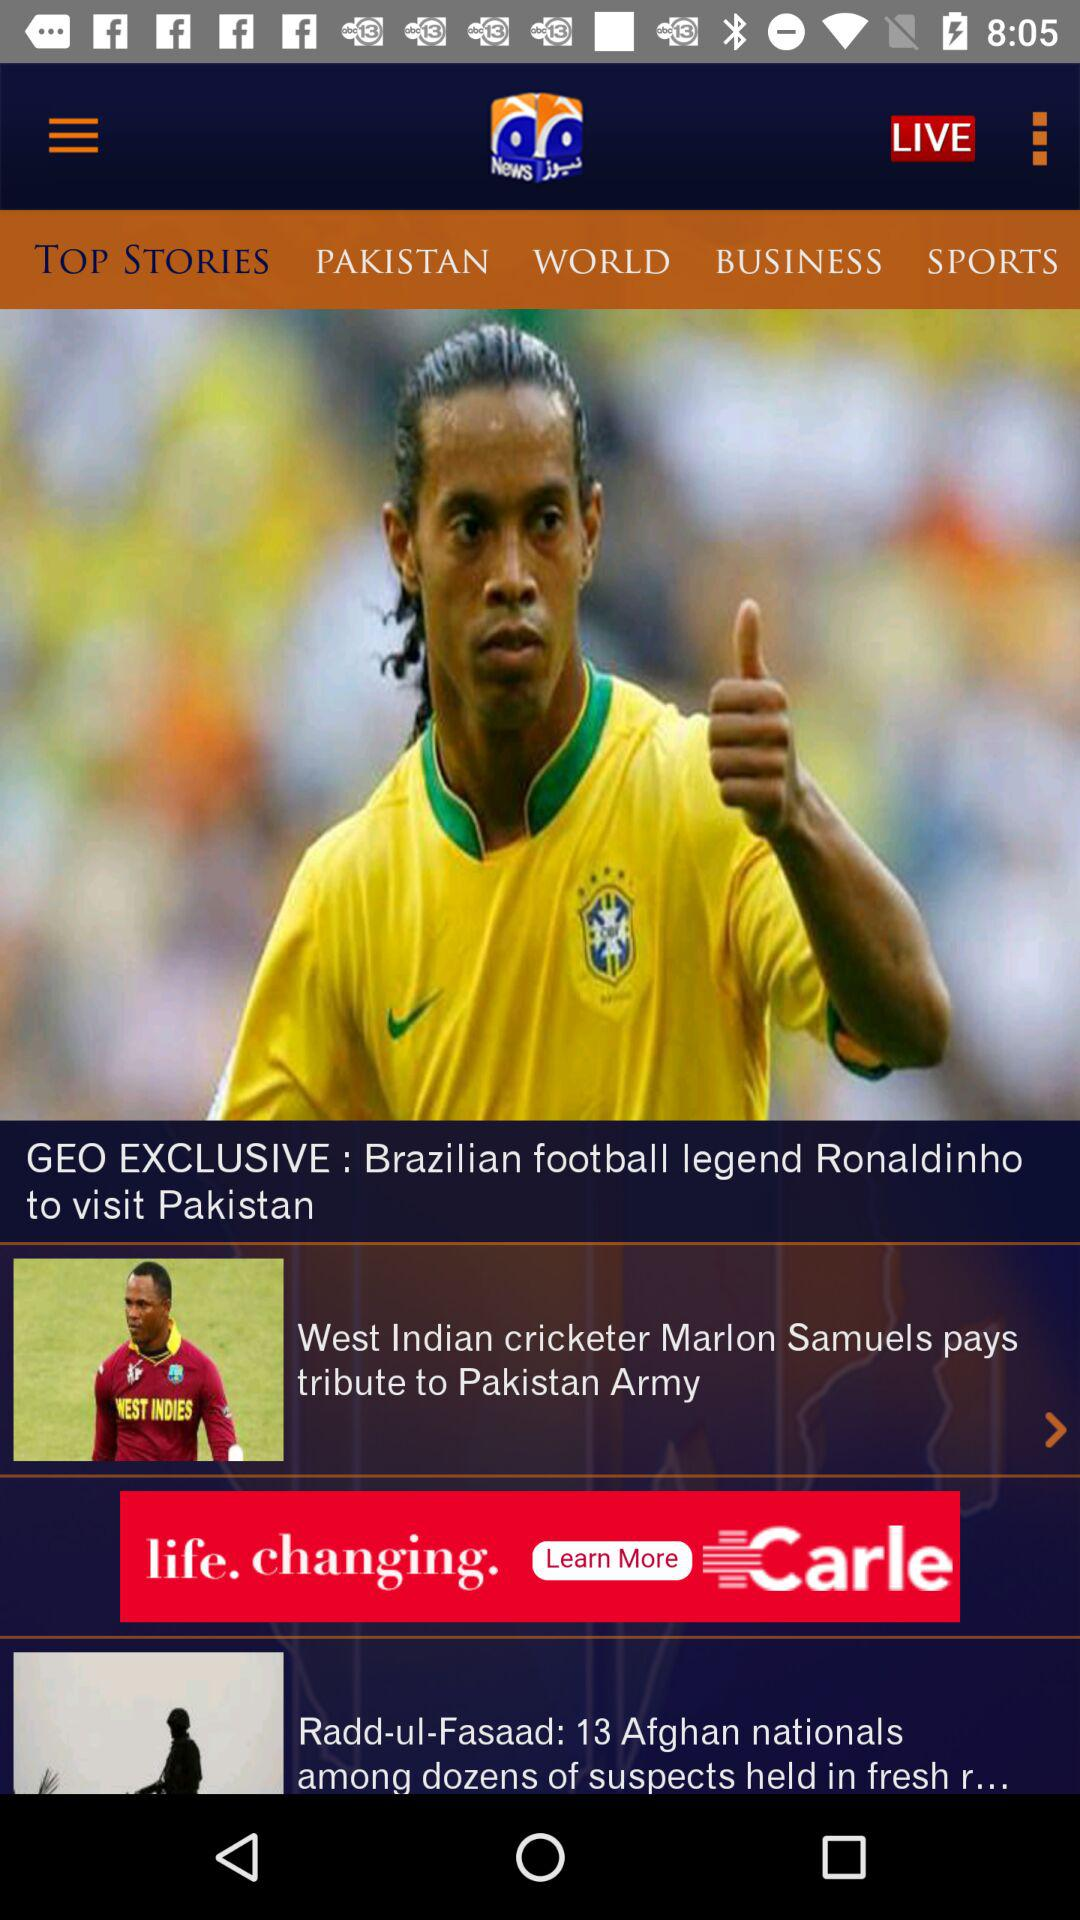Which tab is selected? The selected tab is "TOP STORIES". 